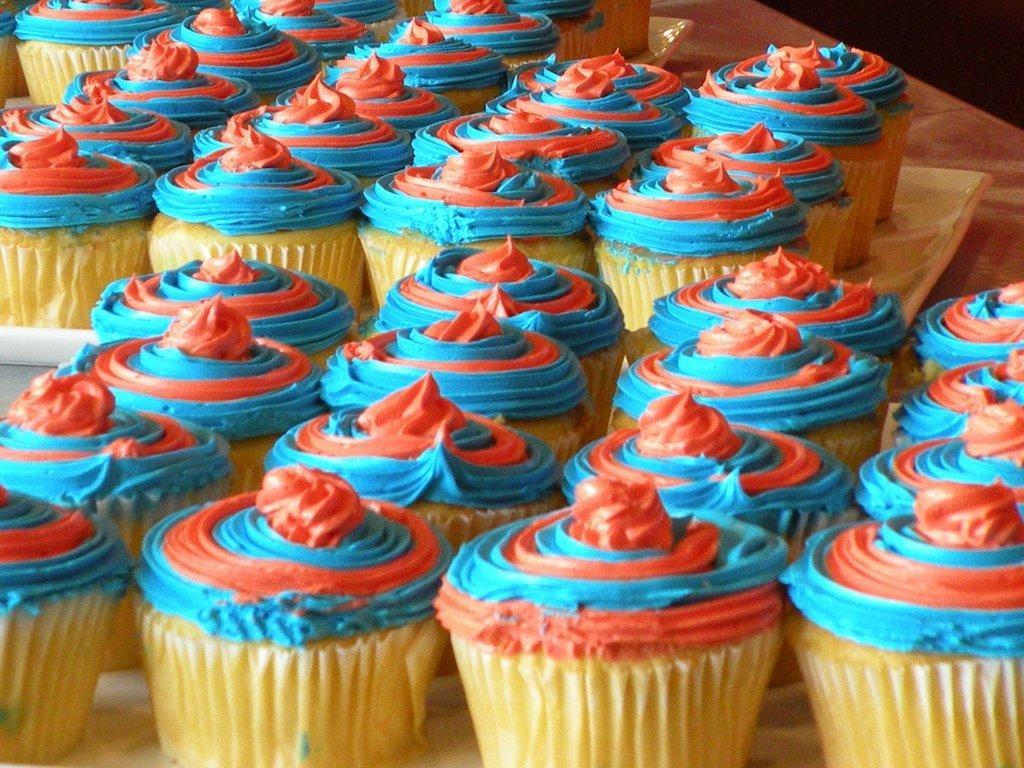Please provide a concise description of this image. In this image we can see cupcakes and a tray placed on the table. 